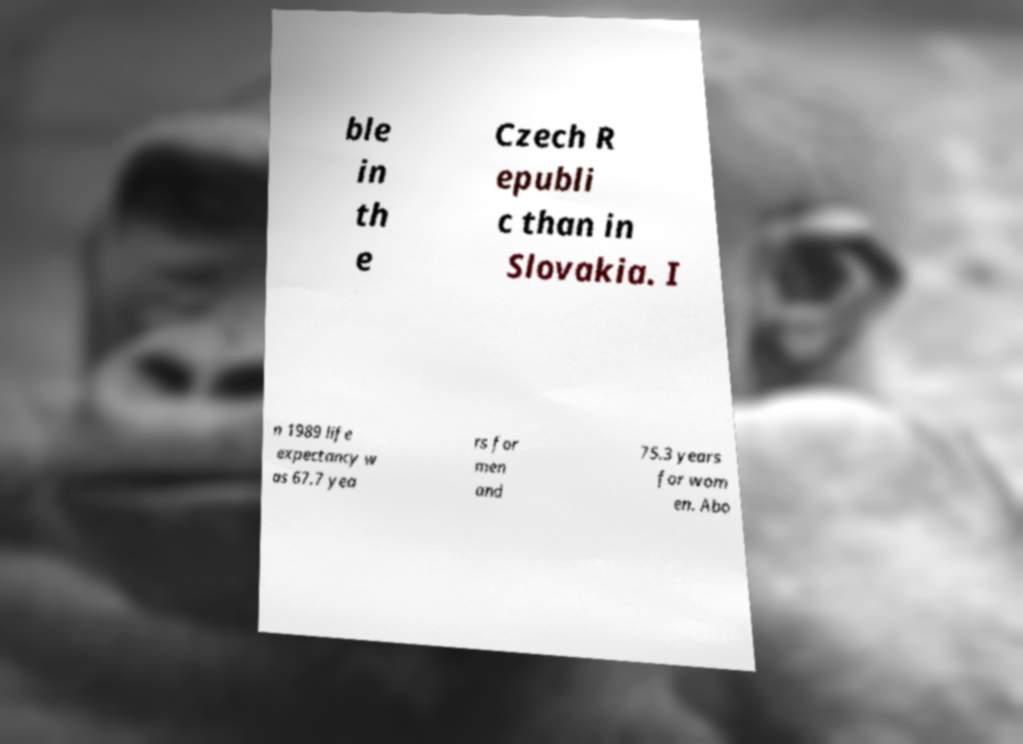What messages or text are displayed in this image? I need them in a readable, typed format. ble in th e Czech R epubli c than in Slovakia. I n 1989 life expectancy w as 67.7 yea rs for men and 75.3 years for wom en. Abo 